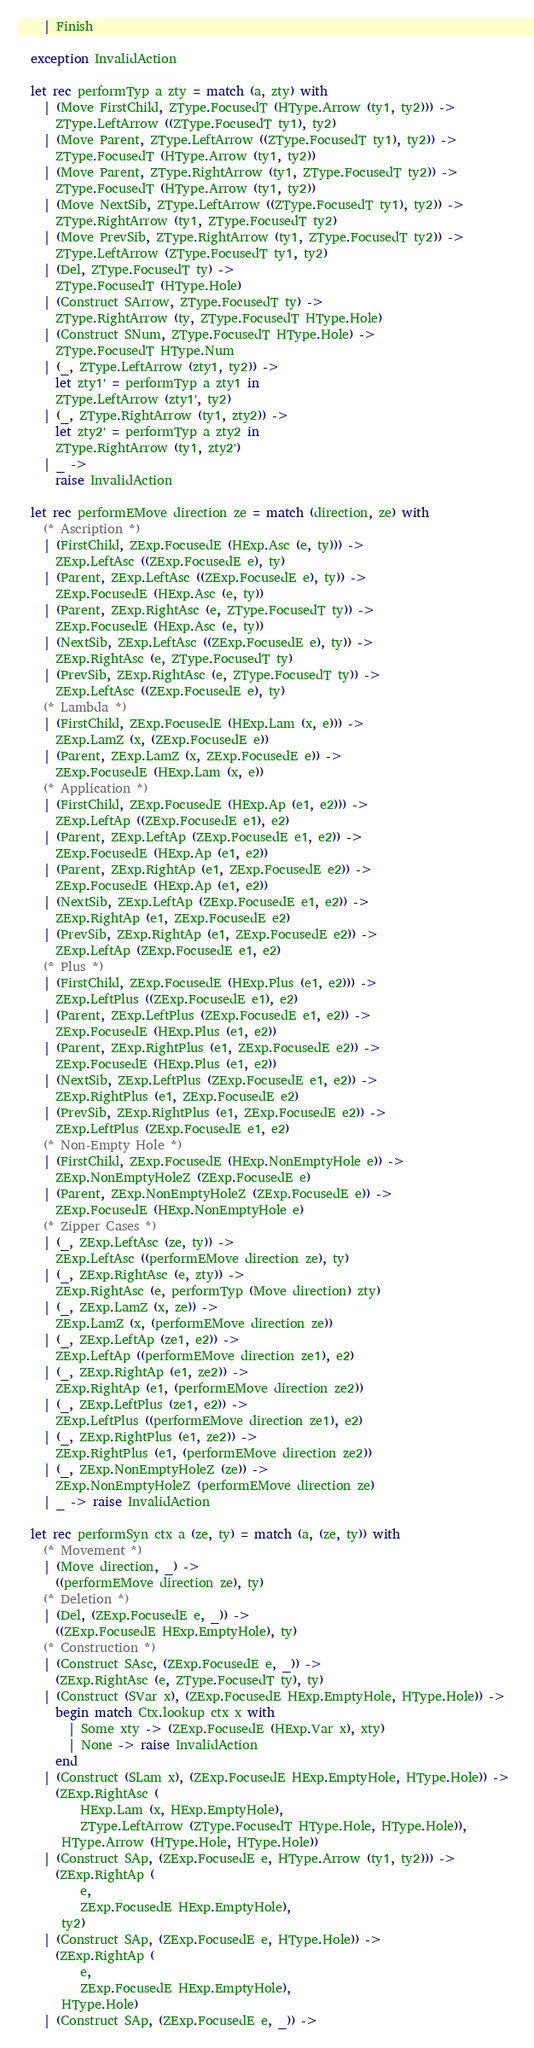<code> <loc_0><loc_0><loc_500><loc_500><_OCaml_>    | Finish

  exception InvalidAction

  let rec performTyp a zty = match (a, zty) with 
    | (Move FirstChild, ZType.FocusedT (HType.Arrow (ty1, ty2))) -> 
      ZType.LeftArrow ((ZType.FocusedT ty1), ty2)
    | (Move Parent, ZType.LeftArrow ((ZType.FocusedT ty1), ty2)) -> 
      ZType.FocusedT (HType.Arrow (ty1, ty2))
    | (Move Parent, ZType.RightArrow (ty1, ZType.FocusedT ty2)) -> 
      ZType.FocusedT (HType.Arrow (ty1, ty2))
    | (Move NextSib, ZType.LeftArrow ((ZType.FocusedT ty1), ty2)) -> 
      ZType.RightArrow (ty1, ZType.FocusedT ty2)
    | (Move PrevSib, ZType.RightArrow (ty1, ZType.FocusedT ty2)) -> 
      ZType.LeftArrow (ZType.FocusedT ty1, ty2)
    | (Del, ZType.FocusedT ty) -> 
      ZType.FocusedT (HType.Hole)
    | (Construct SArrow, ZType.FocusedT ty) -> 
      ZType.RightArrow (ty, ZType.FocusedT HType.Hole)
    | (Construct SNum, ZType.FocusedT HType.Hole) -> 
      ZType.FocusedT HType.Num
    | (_, ZType.LeftArrow (zty1, ty2)) -> 
      let zty1' = performTyp a zty1 in 
      ZType.LeftArrow (zty1', ty2)
    | (_, ZType.RightArrow (ty1, zty2)) -> 
      let zty2' = performTyp a zty2 in 
      ZType.RightArrow (ty1, zty2')
    | _ -> 
      raise InvalidAction

  let rec performEMove direction ze = match (direction, ze) with 
    (* Ascription *)
    | (FirstChild, ZExp.FocusedE (HExp.Asc (e, ty))) -> 
      ZExp.LeftAsc ((ZExp.FocusedE e), ty)
    | (Parent, ZExp.LeftAsc ((ZExp.FocusedE e), ty)) -> 
      ZExp.FocusedE (HExp.Asc (e, ty))
    | (Parent, ZExp.RightAsc (e, ZType.FocusedT ty)) -> 
      ZExp.FocusedE (HExp.Asc (e, ty))
    | (NextSib, ZExp.LeftAsc ((ZExp.FocusedE e), ty)) -> 
      ZExp.RightAsc (e, ZType.FocusedT ty)
    | (PrevSib, ZExp.RightAsc (e, ZType.FocusedT ty)) -> 
      ZExp.LeftAsc ((ZExp.FocusedE e), ty)
    (* Lambda *)
    | (FirstChild, ZExp.FocusedE (HExp.Lam (x, e))) -> 
      ZExp.LamZ (x, (ZExp.FocusedE e))
    | (Parent, ZExp.LamZ (x, ZExp.FocusedE e)) -> 
      ZExp.FocusedE (HExp.Lam (x, e))
    (* Application *)
    | (FirstChild, ZExp.FocusedE (HExp.Ap (e1, e2))) -> 
      ZExp.LeftAp ((ZExp.FocusedE e1), e2)
    | (Parent, ZExp.LeftAp (ZExp.FocusedE e1, e2)) -> 
      ZExp.FocusedE (HExp.Ap (e1, e2))
    | (Parent, ZExp.RightAp (e1, ZExp.FocusedE e2)) -> 
      ZExp.FocusedE (HExp.Ap (e1, e2))
    | (NextSib, ZExp.LeftAp (ZExp.FocusedE e1, e2)) -> 
      ZExp.RightAp (e1, ZExp.FocusedE e2)
    | (PrevSib, ZExp.RightAp (e1, ZExp.FocusedE e2)) -> 
      ZExp.LeftAp (ZExp.FocusedE e1, e2)
    (* Plus *)
    | (FirstChild, ZExp.FocusedE (HExp.Plus (e1, e2))) -> 
      ZExp.LeftPlus ((ZExp.FocusedE e1), e2)
    | (Parent, ZExp.LeftPlus (ZExp.FocusedE e1, e2)) -> 
      ZExp.FocusedE (HExp.Plus (e1, e2))
    | (Parent, ZExp.RightPlus (e1, ZExp.FocusedE e2)) -> 
      ZExp.FocusedE (HExp.Plus (e1, e2))
    | (NextSib, ZExp.LeftPlus (ZExp.FocusedE e1, e2)) -> 
      ZExp.RightPlus (e1, ZExp.FocusedE e2)
    | (PrevSib, ZExp.RightPlus (e1, ZExp.FocusedE e2)) -> 
      ZExp.LeftPlus (ZExp.FocusedE e1, e2)
    (* Non-Empty Hole *)
    | (FirstChild, ZExp.FocusedE (HExp.NonEmptyHole e)) -> 
      ZExp.NonEmptyHoleZ (ZExp.FocusedE e)
    | (Parent, ZExp.NonEmptyHoleZ (ZExp.FocusedE e)) -> 
      ZExp.FocusedE (HExp.NonEmptyHole e)
    (* Zipper Cases *)
    | (_, ZExp.LeftAsc (ze, ty)) -> 
      ZExp.LeftAsc ((performEMove direction ze), ty)
    | (_, ZExp.RightAsc (e, zty)) -> 
      ZExp.RightAsc (e, performTyp (Move direction) zty)
    | (_, ZExp.LamZ (x, ze)) -> 
      ZExp.LamZ (x, (performEMove direction ze))
    | (_, ZExp.LeftAp (ze1, e2)) -> 
      ZExp.LeftAp ((performEMove direction ze1), e2)
    | (_, ZExp.RightAp (e1, ze2)) -> 
      ZExp.RightAp (e1, (performEMove direction ze2))
    | (_, ZExp.LeftPlus (ze1, e2)) -> 
      ZExp.LeftPlus ((performEMove direction ze1), e2)
    | (_, ZExp.RightPlus (e1, ze2)) -> 
      ZExp.RightPlus (e1, (performEMove direction ze2))
    | (_, ZExp.NonEmptyHoleZ (ze)) -> 
      ZExp.NonEmptyHoleZ (performEMove direction ze)
    | _ -> raise InvalidAction

  let rec performSyn ctx a (ze, ty) = match (a, (ze, ty)) with 
    (* Movement *)
    | (Move direction, _) -> 
      ((performEMove direction ze), ty)
    (* Deletion *)
    | (Del, (ZExp.FocusedE e, _)) -> 
      ((ZExp.FocusedE HExp.EmptyHole), ty)
    (* Construction *)
    | (Construct SAsc, (ZExp.FocusedE e, _)) -> 
      (ZExp.RightAsc (e, ZType.FocusedT ty), ty)
    | (Construct (SVar x), (ZExp.FocusedE HExp.EmptyHole, HType.Hole)) -> 
      begin match Ctx.lookup ctx x with 
        | Some xty -> (ZExp.FocusedE (HExp.Var x), xty)
        | None -> raise InvalidAction
      end
    | (Construct (SLam x), (ZExp.FocusedE HExp.EmptyHole, HType.Hole)) -> 
      (ZExp.RightAsc (
          HExp.Lam (x, HExp.EmptyHole), 
          ZType.LeftArrow (ZType.FocusedT HType.Hole, HType.Hole)),
       HType.Arrow (HType.Hole, HType.Hole))
    | (Construct SAp, (ZExp.FocusedE e, HType.Arrow (ty1, ty2))) -> 
      (ZExp.RightAp (
          e,
          ZExp.FocusedE HExp.EmptyHole), 
       ty2)
    | (Construct SAp, (ZExp.FocusedE e, HType.Hole)) -> 
      (ZExp.RightAp (
          e, 
          ZExp.FocusedE HExp.EmptyHole), 
       HType.Hole)
    | (Construct SAp, (ZExp.FocusedE e, _)) -> </code> 